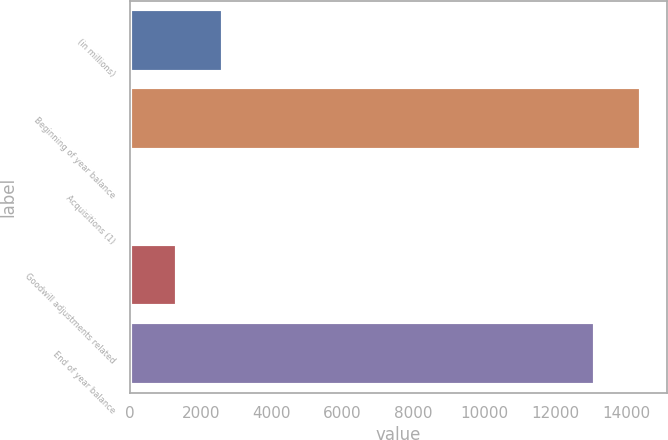<chart> <loc_0><loc_0><loc_500><loc_500><bar_chart><fcel>(in millions)<fcel>Beginning of year balance<fcel>Acquisitions (1)<fcel>Goodwill adjustments related<fcel>End of year balance<nl><fcel>2635.8<fcel>14428.9<fcel>14<fcel>1324.9<fcel>13118<nl></chart> 